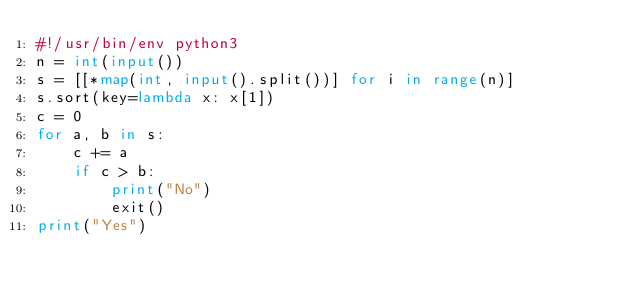Convert code to text. <code><loc_0><loc_0><loc_500><loc_500><_Python_>#!/usr/bin/env python3
n = int(input())
s = [[*map(int, input().split())] for i in range(n)]
s.sort(key=lambda x: x[1])
c = 0
for a, b in s:
    c += a
    if c > b:
        print("No")
        exit()
print("Yes")
</code> 